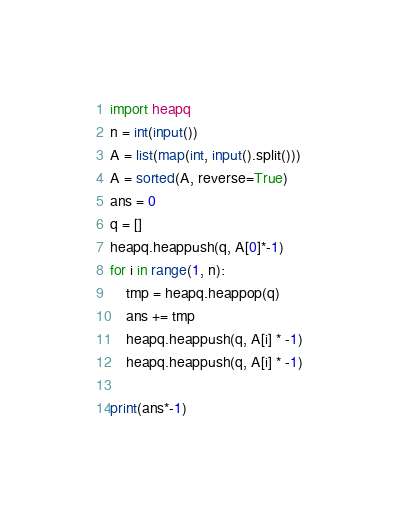<code> <loc_0><loc_0><loc_500><loc_500><_Python_>import heapq
n = int(input())
A = list(map(int, input().split()))
A = sorted(A, reverse=True)
ans = 0
q = []
heapq.heappush(q, A[0]*-1)
for i in range(1, n):
    tmp = heapq.heappop(q)
    ans += tmp
    heapq.heappush(q, A[i] * -1)
    heapq.heappush(q, A[i] * -1)

print(ans*-1)</code> 